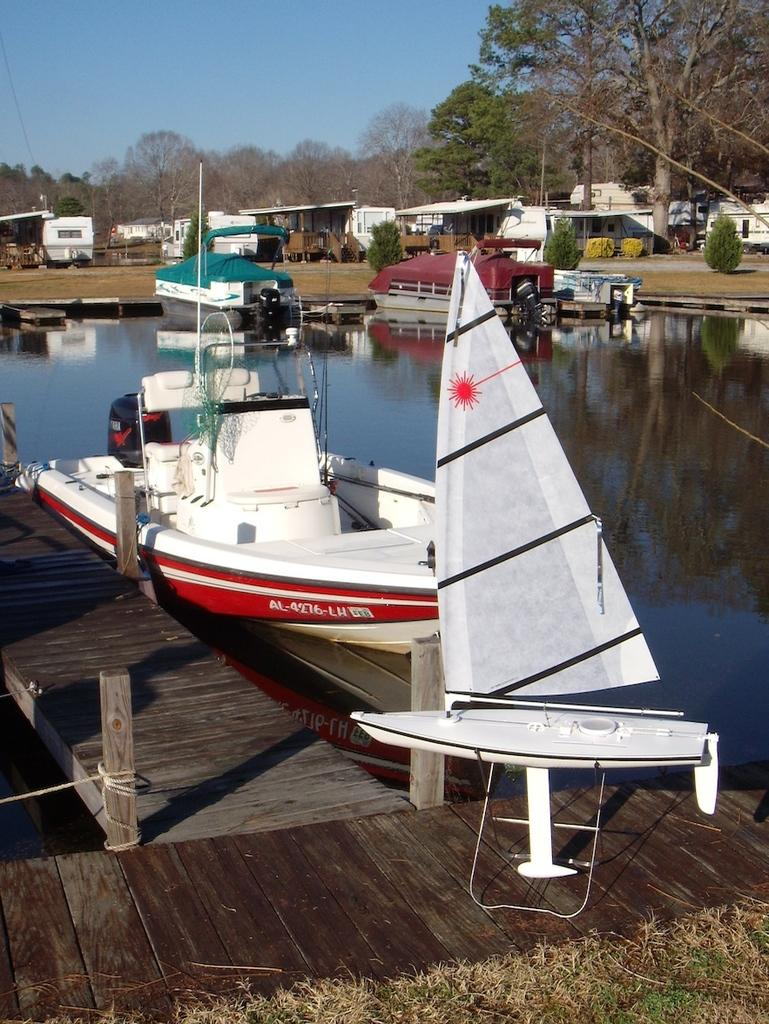What is happening on the water in the image? There are boats on water in the image. What type of surface can be seen in the image? There is a path in the image. What type of vegetation is present in the image? There is grass in the image. What type of structures are present in the image? There are wooden poles and houses in the image. What type of material is visible in the image? There is a rope in the image. What type of natural elements are present in the image? There are trees in the image. What can be seen in the background of the image? The sky is visible in the background of the image. What type of precipitation can be seen falling from the sky in the image? There is no precipitation visible in the image; it only shows boats on water, a path, grass, wooden poles, houses, a rope, trees, and the sky. What type of weather phenomenon can be heard in the image? There is no sound in the image, so it is not possible to determine if any weather phenomena, such as thunder, can be heard. 